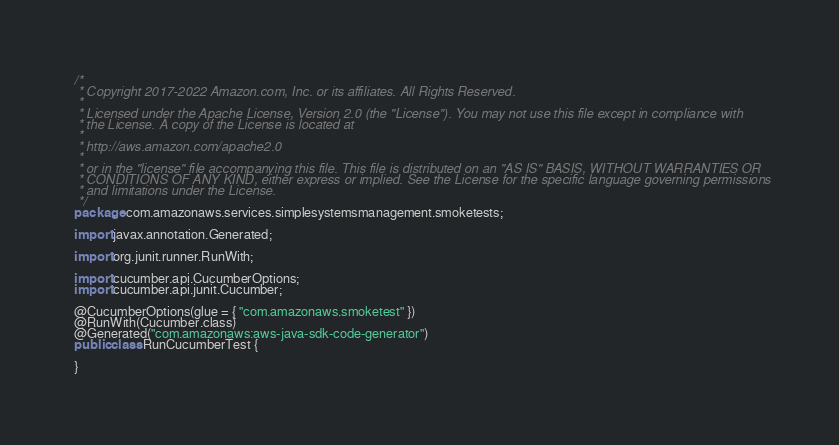Convert code to text. <code><loc_0><loc_0><loc_500><loc_500><_Java_>/*
 * Copyright 2017-2022 Amazon.com, Inc. or its affiliates. All Rights Reserved.
 * 
 * Licensed under the Apache License, Version 2.0 (the "License"). You may not use this file except in compliance with
 * the License. A copy of the License is located at
 * 
 * http://aws.amazon.com/apache2.0
 * 
 * or in the "license" file accompanying this file. This file is distributed on an "AS IS" BASIS, WITHOUT WARRANTIES OR
 * CONDITIONS OF ANY KIND, either express or implied. See the License for the specific language governing permissions
 * and limitations under the License.
 */
package com.amazonaws.services.simplesystemsmanagement.smoketests;

import javax.annotation.Generated;

import org.junit.runner.RunWith;

import cucumber.api.CucumberOptions;
import cucumber.api.junit.Cucumber;

@CucumberOptions(glue = { "com.amazonaws.smoketest" })
@RunWith(Cucumber.class)
@Generated("com.amazonaws:aws-java-sdk-code-generator")
public class RunCucumberTest {

}
</code> 